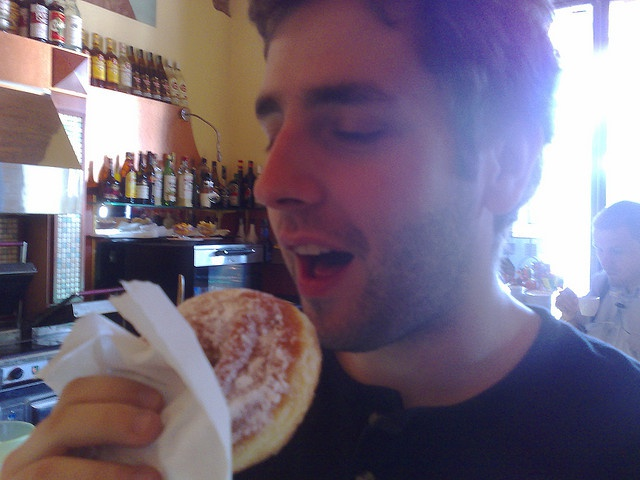Describe the objects in this image and their specific colors. I can see people in darkgray, black, purple, and gray tones, donut in darkgray, gray, and brown tones, bottle in darkgray, black, gray, maroon, and white tones, people in darkgray and gray tones, and oven in darkgray, black, navy, gray, and white tones in this image. 